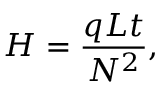Convert formula to latex. <formula><loc_0><loc_0><loc_500><loc_500>H = { \frac { q L t } { N ^ { 2 } } } ,</formula> 